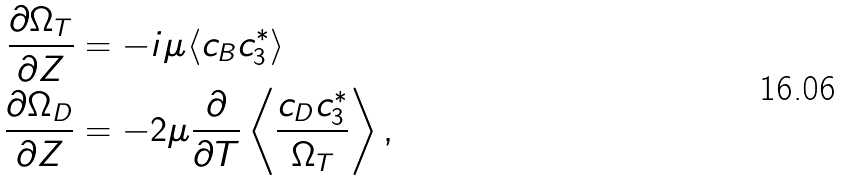Convert formula to latex. <formula><loc_0><loc_0><loc_500><loc_500>\frac { \partial \Omega _ { T } } { \partial Z } & = - i \mu \langle c _ { B } c _ { 3 } ^ { * } \rangle \\ \frac { \partial \Omega _ { D } } { \partial Z } & = - 2 \mu \frac { \partial } { \partial T } \left \langle \frac { c _ { D } c _ { 3 } ^ { * } } { \Omega _ { T } } \right \rangle ,</formula> 